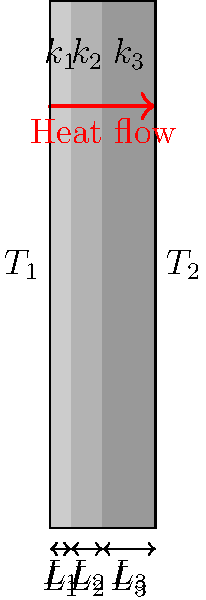A multi-layered wall consists of three materials with thermal conductivities $k_1$, $k_2$, and $k_3$, and thicknesses $L_1$, $L_2$, and $L_3$ respectively. The temperatures on the inner and outer surfaces are $T_1$ and $T_2$. If the heat transfer rate through the wall is 500 W/m², and $k_1 = 0.5$ W/mK, $k_2 = 0.3$ W/mK, $k_3 = 0.2$ W/mK, $L_1 = 0.02$ m, $L_2 = 0.03$ m, and $L_3 = 0.05$ m, calculate the temperature difference $(T_1 - T_2)$ across the wall. To solve this problem, we'll use the concept of thermal resistance in series for a multi-layered wall. Here's the step-by-step solution:

1) The total thermal resistance of the wall is the sum of individual layer resistances:

   $R_{total} = R_1 + R_2 + R_3 = \frac{L_1}{k_1} + \frac{L_2}{k_2} + \frac{L_3}{k_3}$

2) Calculate each layer's resistance:
   $R_1 = \frac{0.02}{0.5} = 0.04$ m²K/W
   $R_2 = \frac{0.03}{0.3} = 0.1$ m²K/W
   $R_3 = \frac{0.05}{0.2} = 0.25$ m²K/W

3) Calculate total resistance:
   $R_{total} = 0.04 + 0.1 + 0.25 = 0.39$ m²K/W

4) Use Fourier's Law of heat conduction:
   $q = \frac{T_1 - T_2}{R_{total}}$

   Where $q$ is the heat transfer rate (500 W/m²)

5) Rearrange the equation to solve for $(T_1 - T_2)$:
   $T_1 - T_2 = q \times R_{total}$

6) Plug in the values:
   $T_1 - T_2 = 500 \times 0.39 = 195$ K

Therefore, the temperature difference across the wall is 195 K.
Answer: 195 K 